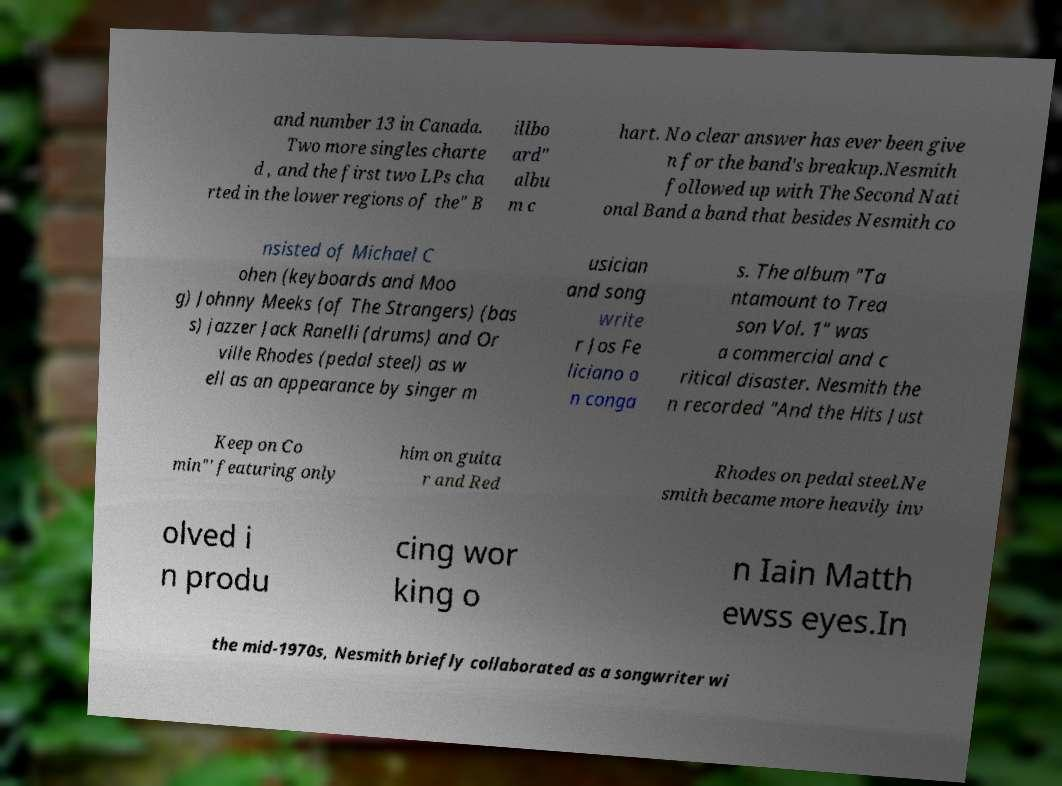For documentation purposes, I need the text within this image transcribed. Could you provide that? and number 13 in Canada. Two more singles charte d , and the first two LPs cha rted in the lower regions of the" B illbo ard" albu m c hart. No clear answer has ever been give n for the band's breakup.Nesmith followed up with The Second Nati onal Band a band that besides Nesmith co nsisted of Michael C ohen (keyboards and Moo g) Johnny Meeks (of The Strangers) (bas s) jazzer Jack Ranelli (drums) and Or ville Rhodes (pedal steel) as w ell as an appearance by singer m usician and song write r Jos Fe liciano o n conga s. The album "Ta ntamount to Trea son Vol. 1" was a commercial and c ritical disaster. Nesmith the n recorded "And the Hits Just Keep on Co min"' featuring only him on guita r and Red Rhodes on pedal steel.Ne smith became more heavily inv olved i n produ cing wor king o n Iain Matth ewss eyes.In the mid-1970s, Nesmith briefly collaborated as a songwriter wi 